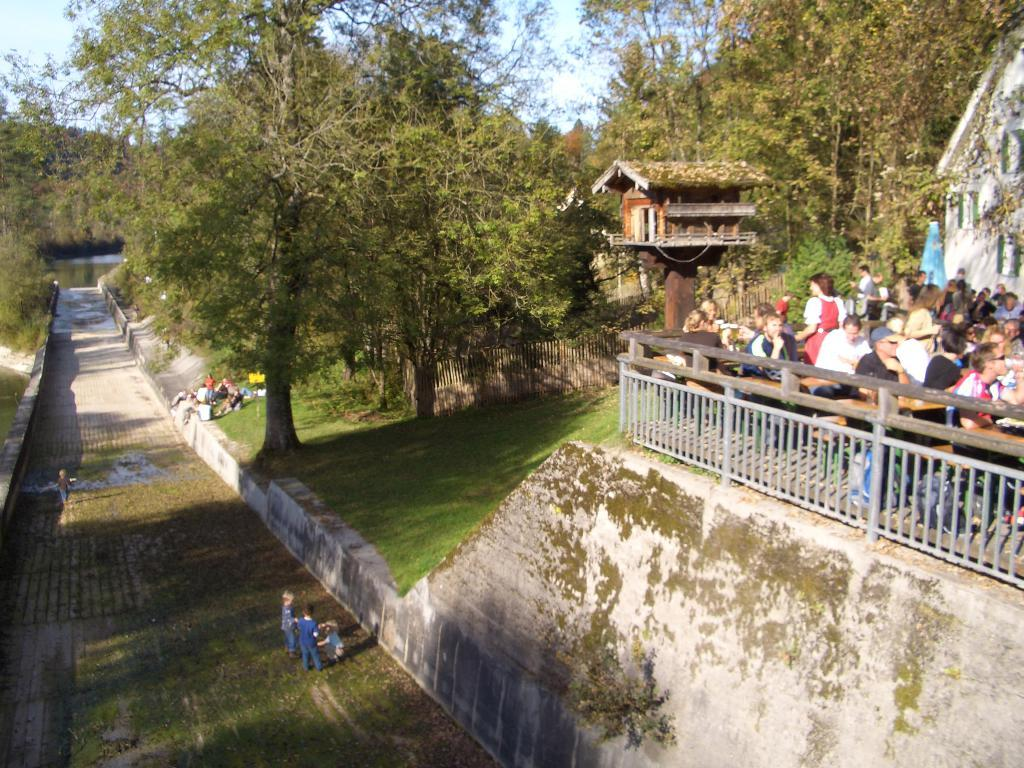How many people are in the image? There is a group of people in the image, but the exact number is not specified. What type of structures can be seen in the image? There are houses in the image. What is the purpose of the fence in the image? The fence is likely used to mark boundaries or provide privacy. What type of vegetation is present in the image? There are trees and grass in the image. What is the natural feature visible in the image? There is water visible in the image. What is visible in the background of the image? The sky is visible in the background of the image. What language is being spoken by the people in the image? There is no information about the language being spoken by the people in the image. What substance is being used to write in the notebook in the image? There is no notebook present in the image. 